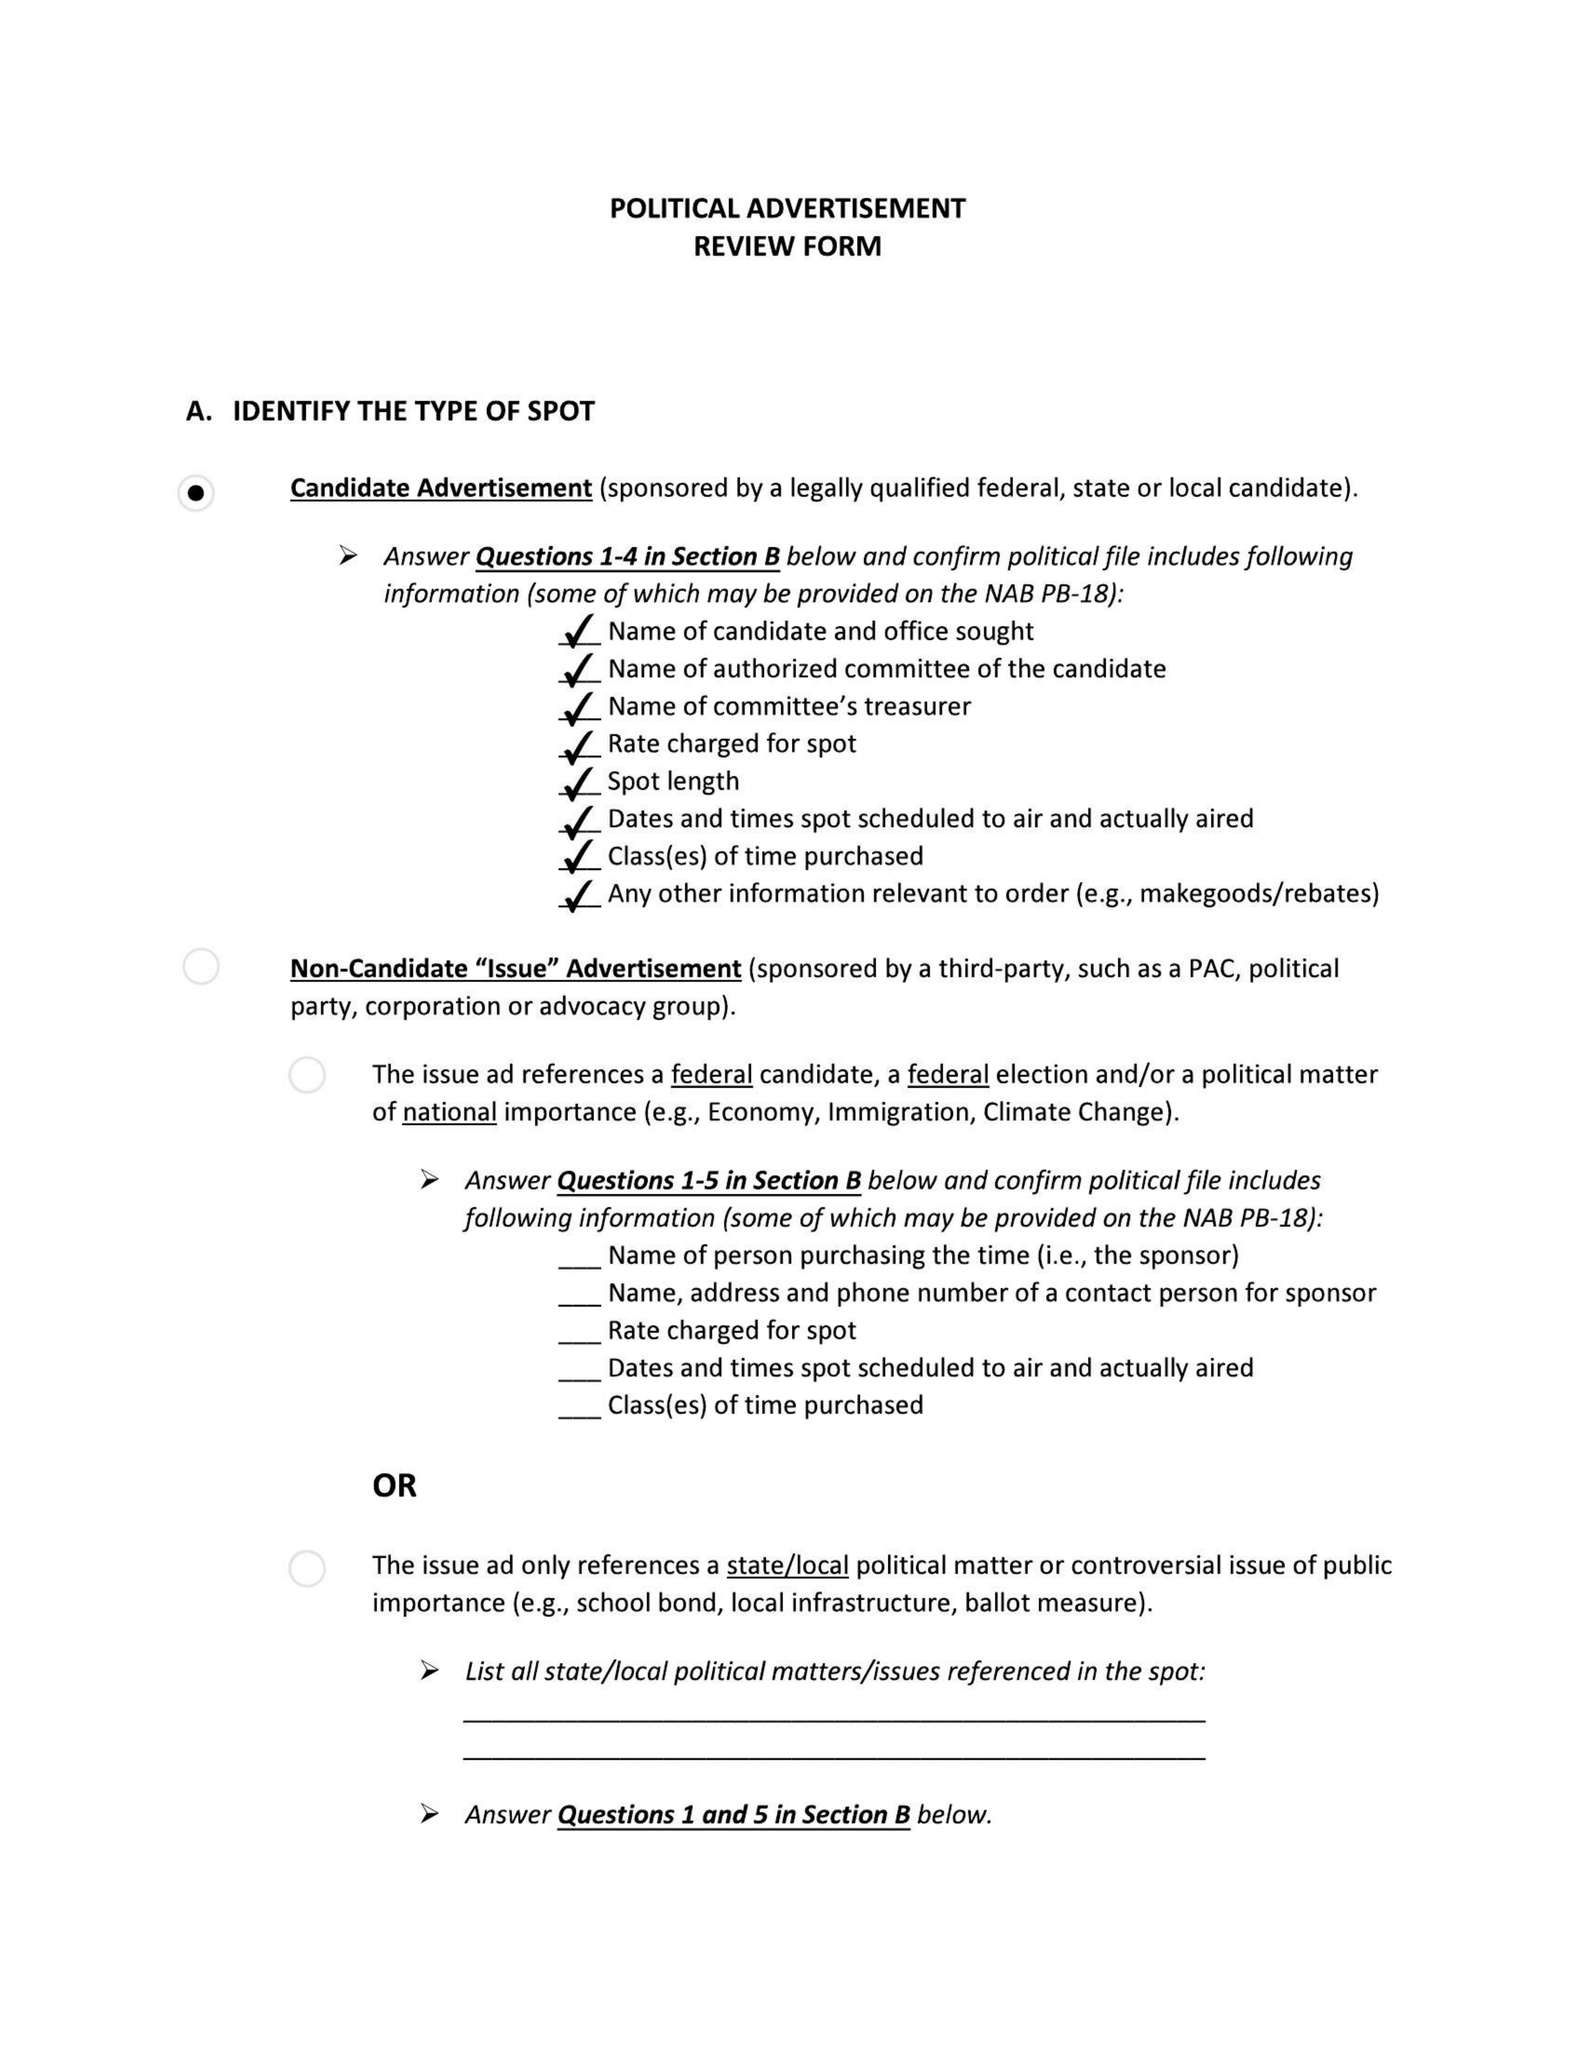What is the value for the contract_num?
Answer the question using a single word or phrase. None 